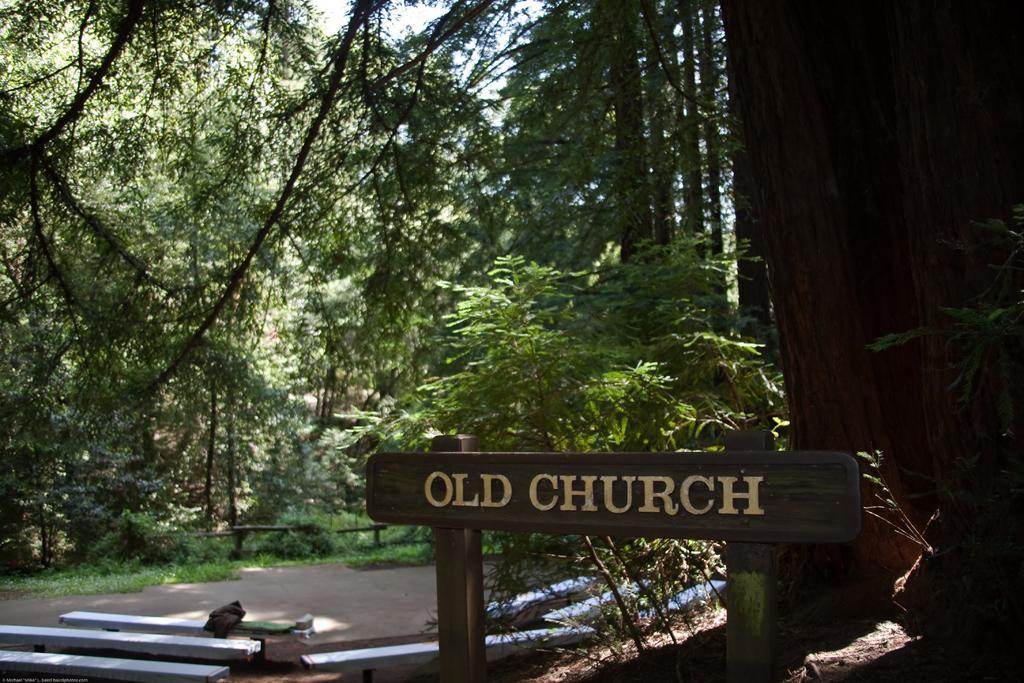How would you summarize this image in a sentence or two? In this image, we can see some benches. There are trees in the middle of the image. There is a board at the bottom of the image. 